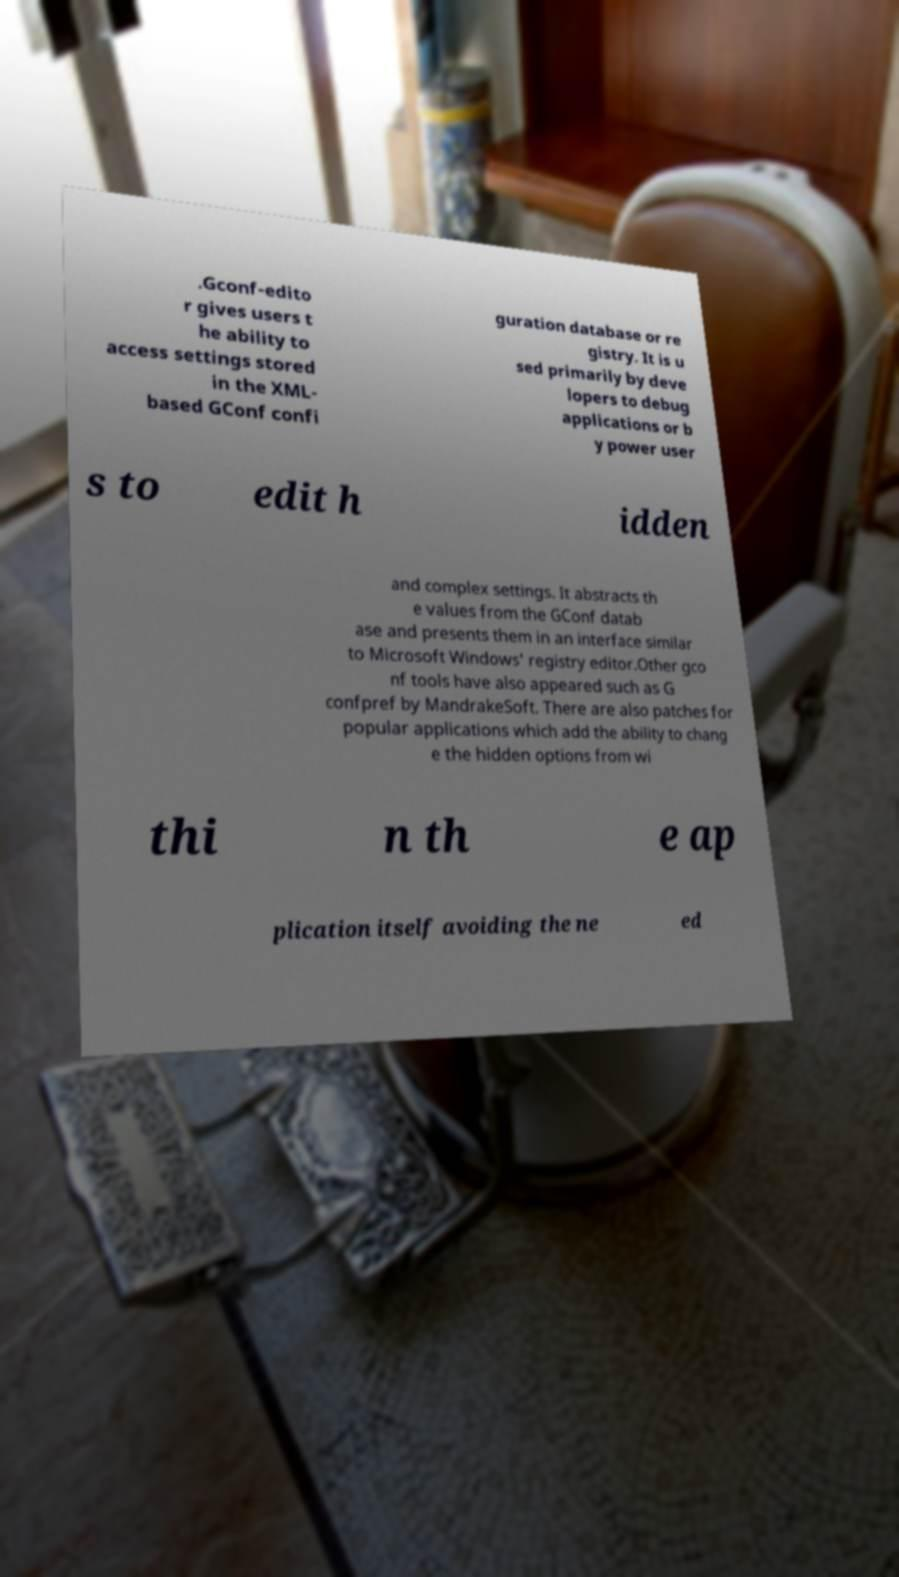For documentation purposes, I need the text within this image transcribed. Could you provide that? .Gconf-edito r gives users t he ability to access settings stored in the XML- based GConf confi guration database or re gistry. It is u sed primarily by deve lopers to debug applications or b y power user s to edit h idden and complex settings. It abstracts th e values from the GConf datab ase and presents them in an interface similar to Microsoft Windows' registry editor.Other gco nf tools have also appeared such as G confpref by MandrakeSoft. There are also patches for popular applications which add the ability to chang e the hidden options from wi thi n th e ap plication itself avoiding the ne ed 